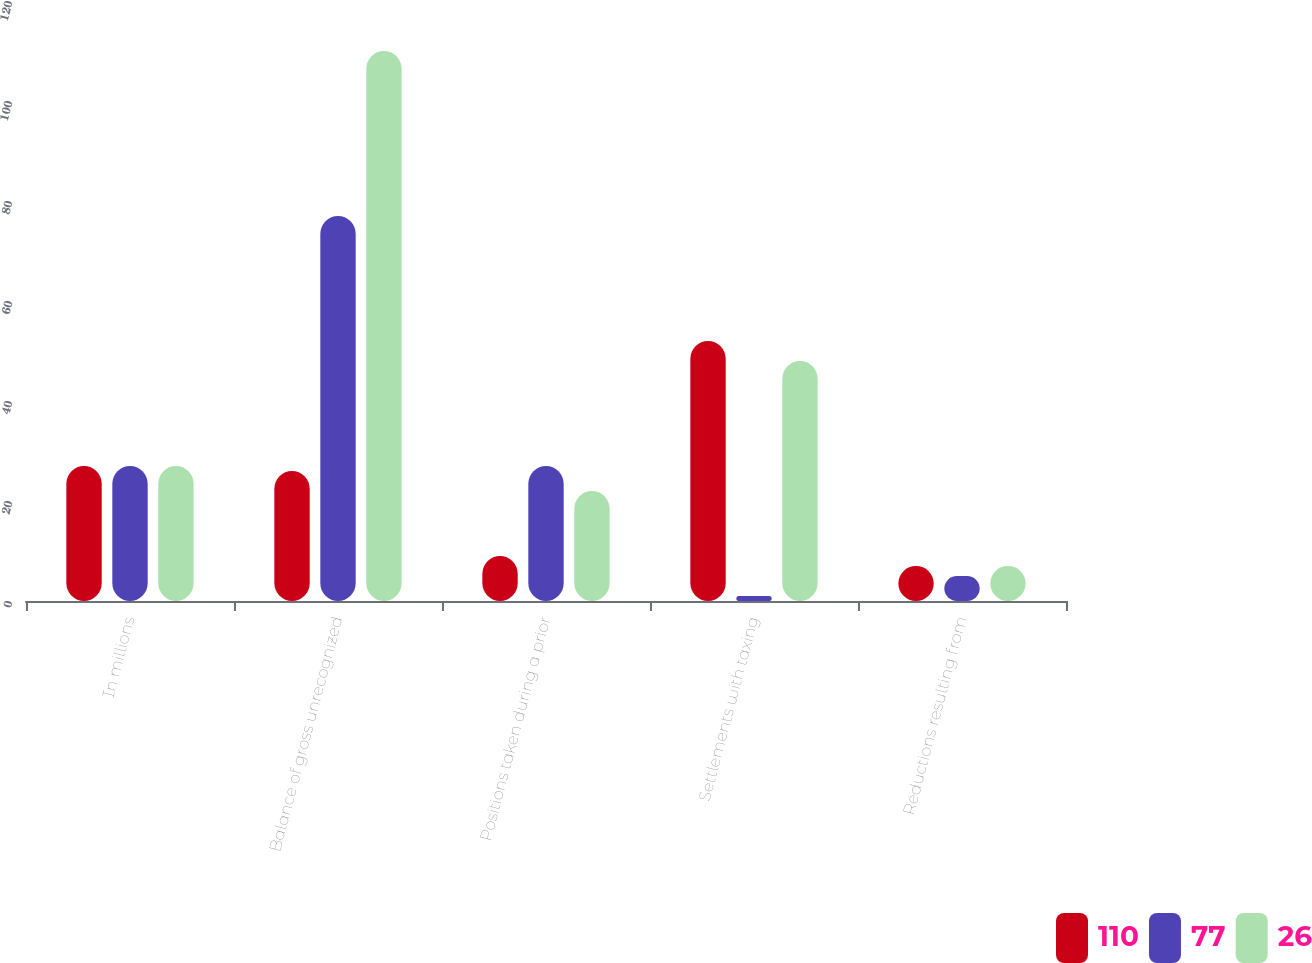Convert chart. <chart><loc_0><loc_0><loc_500><loc_500><stacked_bar_chart><ecel><fcel>In millions<fcel>Balance of gross unrecognized<fcel>Positions taken during a prior<fcel>Settlements with taxing<fcel>Reductions resulting from<nl><fcel>110<fcel>27<fcel>26<fcel>9<fcel>52<fcel>7<nl><fcel>77<fcel>27<fcel>77<fcel>27<fcel>1<fcel>5<nl><fcel>26<fcel>27<fcel>110<fcel>22<fcel>48<fcel>7<nl></chart> 